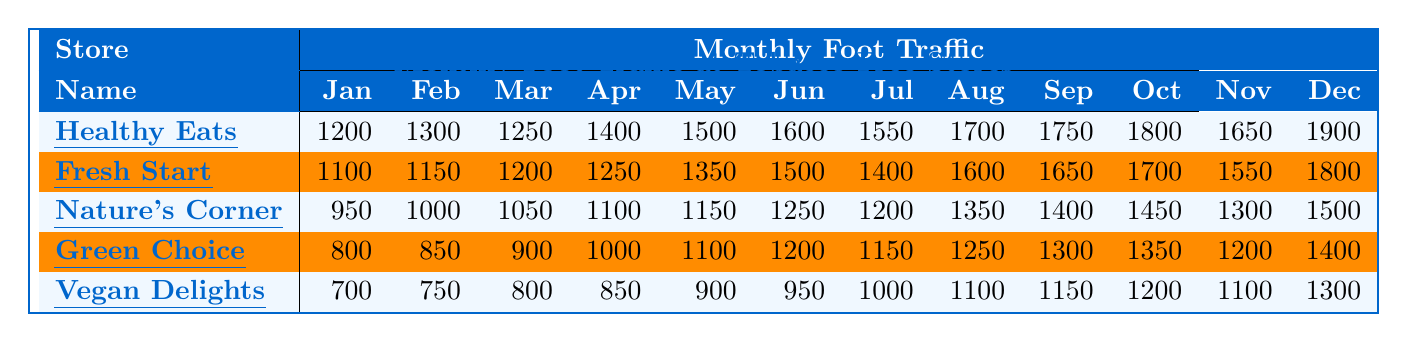What is the foot traffic for Healthy Eats Market in December? Referring to the table, the foot traffic for Healthy Eats Market in December is listed as 1900.
Answer: 1900 What month had the highest foot traffic for Nature's Corner? Looking through the monthly values for Nature's Corner, the highest foot traffic is in December with a value of 1500.
Answer: December Which store had the lowest foot traffic in January? By inspecting the foot traffic values for January, Vegan Delights had the lowest foot traffic at 700.
Answer: Vegan Delights What is the average foot traffic for Fresh Start Grocery for the first half of the year (January to June)? To find the average, add the foot traffic from January (1100), February (1150), March (1200), April (1250), May (1350), and June (1500) which sums to 7,650. Then divide by 6, resulting in an average foot traffic of 1275.
Answer: 1275 Did Vegan Delights have more foot traffic than Green Choice Foods in August? Comparing the values, Vegan Delights had 1100 in August, while Green Choice Foods had 1250. Since 1100 is less than 1250, the answer is no.
Answer: No How much more foot traffic did Healthy Eats Market have in October compared to Vegan Delights? In October, Healthy Eats Market had 1800, and Vegan Delights had 1200. The difference is 1800 - 1200 = 600.
Answer: 600 What is the total foot traffic for all stores in June? Adding the foot traffic in June: Healthy Eats Market (1600) + Fresh Start Grocery (1500) + Nature's Corner (1250) + Green Choice Foods (1200) + Vegan Delights (950) results in a total of 5,500.
Answer: 5500 Which store showed the most consistent growth in foot traffic from January to December? By observing the monthly foot traffic values, Healthy Eats Market shows consistent growth each month, with no decreases.
Answer: Healthy Eats Market How many months did Fresh Start Grocery have a foot traffic figure above 1600? Fresh Start Grocery had above 1600 in June, August, September, October, and December, which totals 5 months.
Answer: 5 What was the total foot traffic for the store with the highest foot traffic in September? The store with the highest foot traffic in September is Healthy Eats Market with 1750. To get the total for all months, we sum 1200 + 1300 + 1250 + 1400 + 1500 + 1600 + 1550 + 1700 + 1750 + 1800 + 1650 + 1900, totaling 18,400.
Answer: 18400 